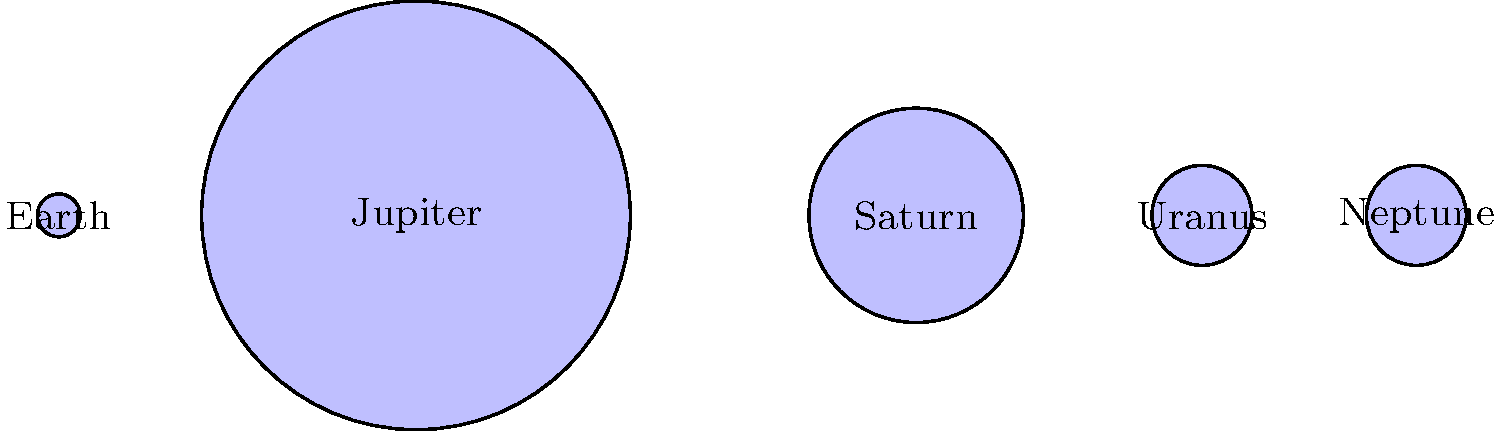As a working professional who contributes to your partner's astronomy blog, you've been asked to write about the relative sizes of planets in our solar system. Based on the diagram, which planet is approximately twice the diameter of Saturn? To determine which planet is approximately twice the diameter of Saturn, let's follow these steps:

1. Observe the relative sizes of the planets in the diagram.
2. Identify Saturn's size as a reference point.
3. Compare the diameters of other planets to Saturn's diameter.

Step 1: The diagram shows five planets: Earth, Jupiter, Saturn, Uranus, and Neptune.

Step 2: Saturn is represented by the second-largest circle in the diagram.

Step 3: Comparing the diameters:
- Earth is much smaller than Saturn.
- Uranus and Neptune appear to be about half the size of Saturn.
- Jupiter is clearly larger than Saturn.

To estimate if Jupiter is twice the diameter of Saturn:
- Saturn's diameter in the diagram is about 15 units.
- Jupiter's diameter in the diagram is about 30 units.

30 units ÷ 15 units = 2

Therefore, Jupiter's diameter is approximately twice that of Saturn in this representation.

In reality, Jupiter's equatorial diameter is about 142,984 km, while Saturn's is about 120,536 km. The ratio is actually closer to 1.19, but for the purposes of this simplified diagram, Jupiter is depicted as roughly twice the diameter of Saturn.
Answer: Jupiter 